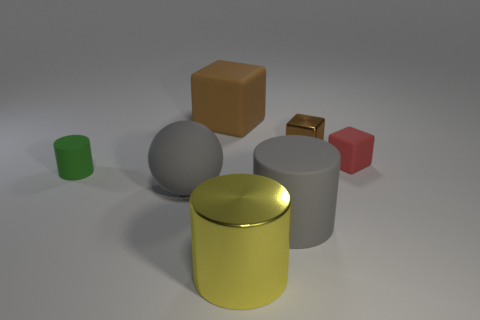There is a object that is the same color as the large matte ball; what shape is it?
Your answer should be very brief. Cylinder. How many red matte cylinders are the same size as the brown metallic object?
Keep it short and to the point. 0. There is a rubber object that is both behind the matte ball and to the left of the large cube; what is its color?
Your answer should be very brief. Green. Is the number of matte cubes that are to the right of the brown matte cube greater than the number of tiny brown cubes?
Keep it short and to the point. No. Are there any matte things?
Keep it short and to the point. Yes. Does the small cylinder have the same color as the large cube?
Offer a very short reply. No. How many big objects are yellow shiny objects or green objects?
Keep it short and to the point. 1. Is there anything else that is the same color as the tiny cylinder?
Provide a succinct answer. No. What is the shape of the gray object that is made of the same material as the gray cylinder?
Offer a terse response. Sphere. There is a cylinder to the right of the large yellow metal object; what is its size?
Provide a short and direct response. Large. 